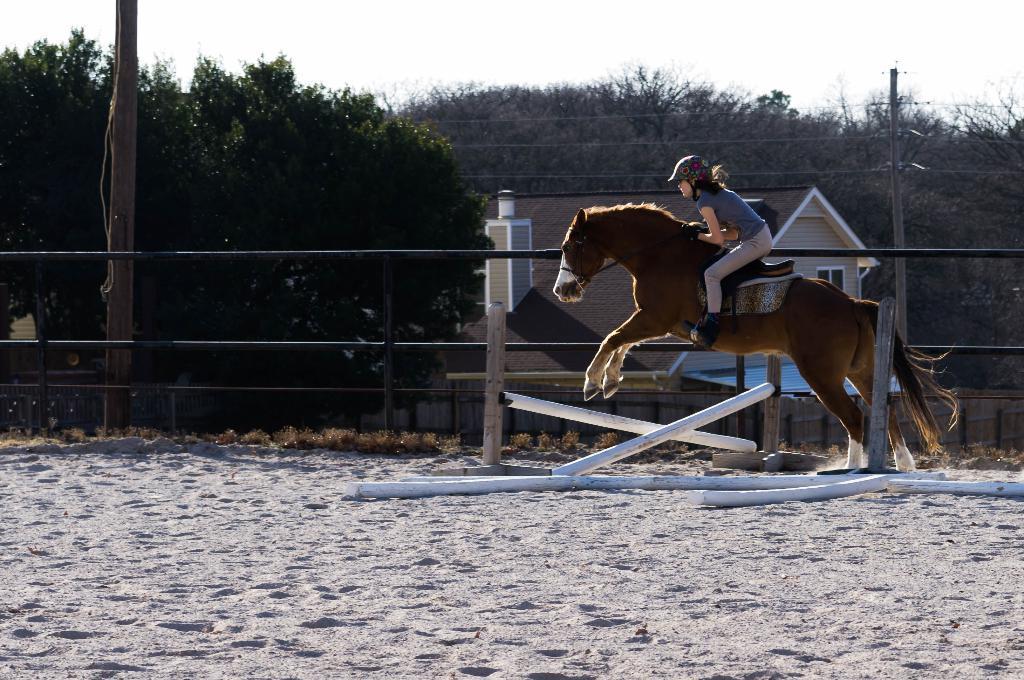How would you summarize this image in a sentence or two? This picture is clicked outside in a city. There is a woman riding horse. She is wearing helmet and boots. In the background there is a house, tree, mountain, sky and a pole. 